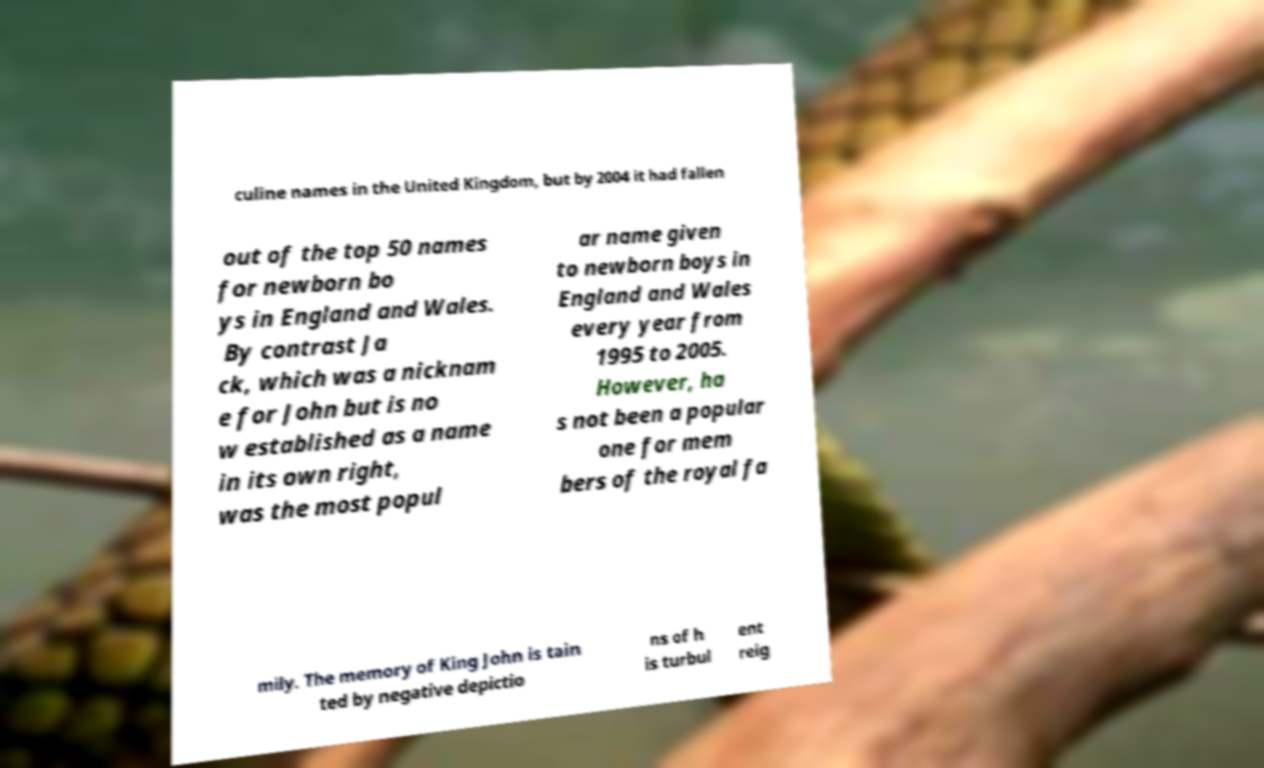Please identify and transcribe the text found in this image. culine names in the United Kingdom, but by 2004 it had fallen out of the top 50 names for newborn bo ys in England and Wales. By contrast Ja ck, which was a nicknam e for John but is no w established as a name in its own right, was the most popul ar name given to newborn boys in England and Wales every year from 1995 to 2005. However, ha s not been a popular one for mem bers of the royal fa mily. The memory of King John is tain ted by negative depictio ns of h is turbul ent reig 